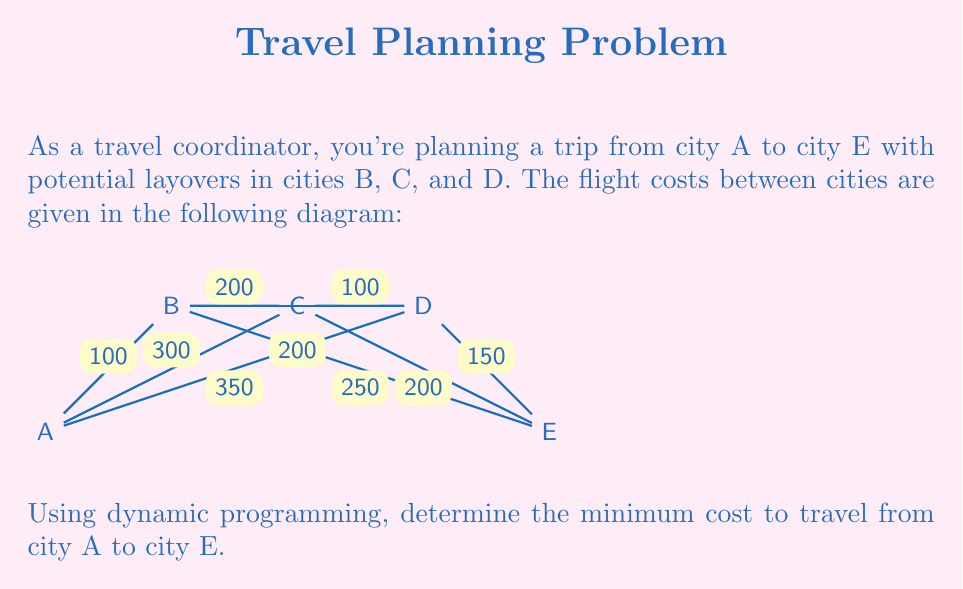Teach me how to tackle this problem. To solve this problem using dynamic programming, we'll follow these steps:

1) Define the subproblem: Let $f(i)$ be the minimum cost to reach city $i$ from city A.

2) Establish the base case: $f(A) = 0$

3) Define the recurrence relation:
   For each city $i$, $f(i) = \min\{f(j) + \text{cost}(j,i)\}$ for all cities $j$ that have a direct flight to $i$.

4) Solve the subproblems in order:

   $f(A) = 0$

   $f(B) = f(A) + 100 = 100$

   $f(C) = \min\{f(A) + 300, f(B) + 200\} = \min\{300, 300\} = 300$

   $f(D) = \min\{f(A) + 350, f(B) + 200, f(C) + 100\} = \min\{350, 300, 400\} = 300$

   $f(E) = \min\{f(B) + 250, f(C) + 200, f(D) + 150\} = \min\{350, 500, 450\} = 350$

5) The minimum cost to reach city E from city A is $f(E) = 350$.

The optimal path is A → B → E, with a total cost of 350.
Answer: 350 